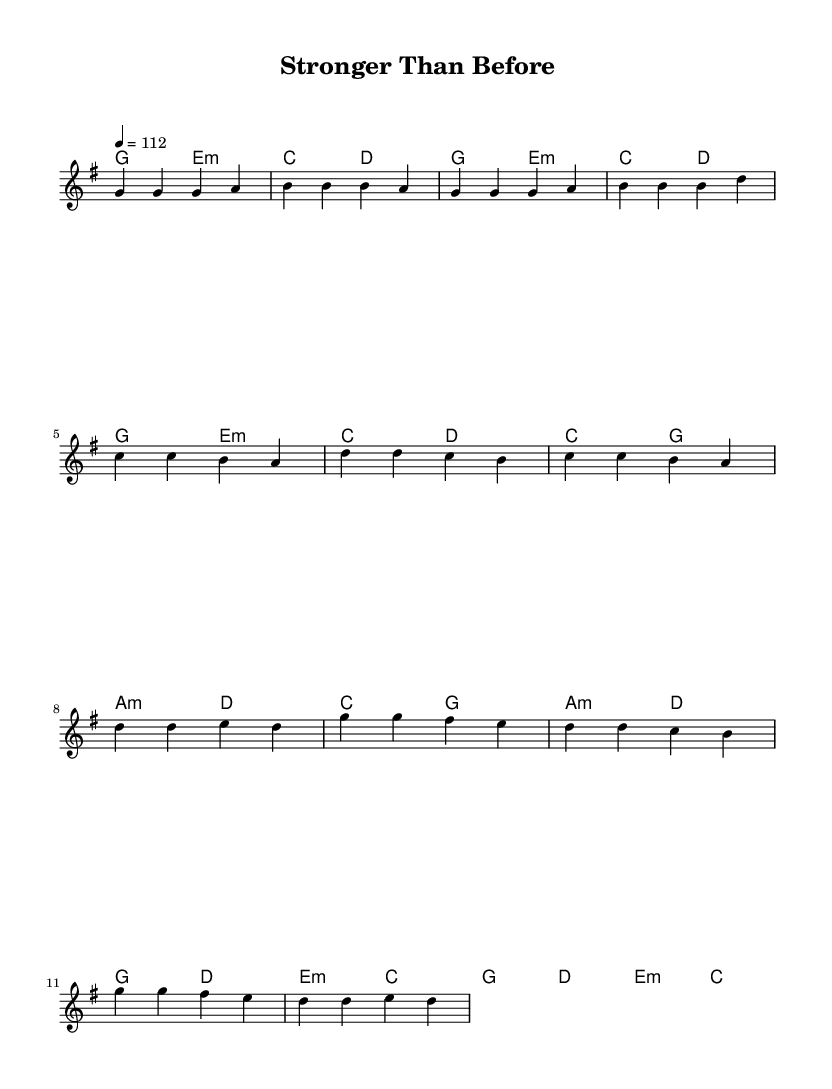What is the key signature of this music? The key signature is G major, which has one sharp (F#). It can be found at the beginning of the staff.
Answer: G major What is the time signature of this music? The time signature is 4/4, indicating that there are four beats in each measure and the quarter note gets one beat. It is shown at the beginning of the score.
Answer: 4/4 What is the tempo marking of this music? The tempo marking is labeled as "4 = 112", which indicates that there are 112 beats per minute. This is shown in the tempo directive at the beginning of the score.
Answer: 112 What is the first chord played in the piece? The first chord in the piece is G major, as seen in the harmony section indicated at the start of the score.
Answer: G major How many measures are there in the chorus? The chorus consists of four measures, as indicated by the grouping of notes and the lyrics section attached to it.
Answer: 4 What is the emotional theme of the song represented in the lyrics? The emotional theme revolves around overcoming challenges and finding inner strength, as reflected in phrases like "stronger than before" and "embracing life, come what may."
Answer: Overcoming challenges What musical form does this song predominantly use? The song uses a verse-pre-chorus-chorus structure, where the verse introduces the theme, followed by a pre-chorus that builds up, leading to the chorus that delivers the main message. This structure is a common design in pop music.
Answer: Verse-pre-chorus-chorus 